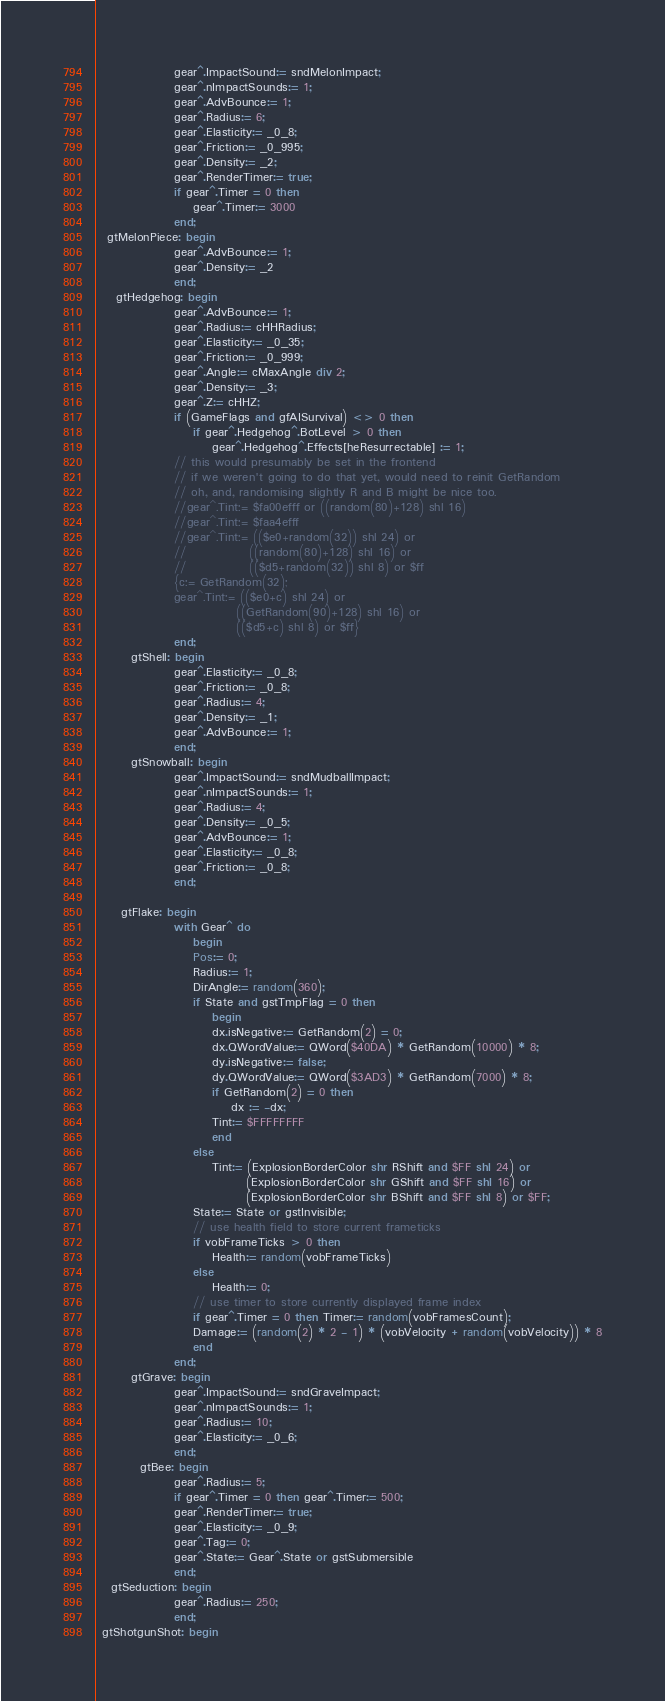Convert code to text. <code><loc_0><loc_0><loc_500><loc_500><_Pascal_>                gear^.ImpactSound:= sndMelonImpact;
                gear^.nImpactSounds:= 1;
                gear^.AdvBounce:= 1;
                gear^.Radius:= 6;
                gear^.Elasticity:= _0_8;
                gear^.Friction:= _0_995;
                gear^.Density:= _2;
                gear^.RenderTimer:= true;
                if gear^.Timer = 0 then
                    gear^.Timer:= 3000
                end;
  gtMelonPiece: begin
                gear^.AdvBounce:= 1;
                gear^.Density:= _2
                end;
    gtHedgehog: begin
                gear^.AdvBounce:= 1;
                gear^.Radius:= cHHRadius;
                gear^.Elasticity:= _0_35;
                gear^.Friction:= _0_999;
                gear^.Angle:= cMaxAngle div 2;
                gear^.Density:= _3;
                gear^.Z:= cHHZ;
                if (GameFlags and gfAISurvival) <> 0 then
                    if gear^.Hedgehog^.BotLevel > 0 then
                        gear^.Hedgehog^.Effects[heResurrectable] := 1;
                // this would presumably be set in the frontend
                // if we weren't going to do that yet, would need to reinit GetRandom
                // oh, and, randomising slightly R and B might be nice too.
                //gear^.Tint:= $fa00efff or ((random(80)+128) shl 16)
                //gear^.Tint:= $faa4efff
                //gear^.Tint:= (($e0+random(32)) shl 24) or
                //             ((random(80)+128) shl 16) or
                //             (($d5+random(32)) shl 8) or $ff
                {c:= GetRandom(32);
                gear^.Tint:= (($e0+c) shl 24) or
                             ((GetRandom(90)+128) shl 16) or
                             (($d5+c) shl 8) or $ff}
                end;
       gtShell: begin
                gear^.Elasticity:= _0_8;
                gear^.Friction:= _0_8;
                gear^.Radius:= 4;
                gear^.Density:= _1;
                gear^.AdvBounce:= 1;
                end;
       gtSnowball: begin
                gear^.ImpactSound:= sndMudballImpact;
                gear^.nImpactSounds:= 1;
                gear^.Radius:= 4;
                gear^.Density:= _0_5;
                gear^.AdvBounce:= 1;
                gear^.Elasticity:= _0_8;
                gear^.Friction:= _0_8;
                end;

     gtFlake: begin
                with Gear^ do
                    begin
                    Pos:= 0;
                    Radius:= 1;
                    DirAngle:= random(360);
                    if State and gstTmpFlag = 0 then
                        begin
                        dx.isNegative:= GetRandom(2) = 0;
                        dx.QWordValue:= QWord($40DA) * GetRandom(10000) * 8;
                        dy.isNegative:= false;
                        dy.QWordValue:= QWord($3AD3) * GetRandom(7000) * 8;
                        if GetRandom(2) = 0 then
                            dx := -dx;
                        Tint:= $FFFFFFFF
                        end
                    else
                        Tint:= (ExplosionBorderColor shr RShift and $FF shl 24) or
                               (ExplosionBorderColor shr GShift and $FF shl 16) or
                               (ExplosionBorderColor shr BShift and $FF shl 8) or $FF;
                    State:= State or gstInvisible;
                    // use health field to store current frameticks
                    if vobFrameTicks > 0 then
                        Health:= random(vobFrameTicks)
                    else
                        Health:= 0;
                    // use timer to store currently displayed frame index
                    if gear^.Timer = 0 then Timer:= random(vobFramesCount);
                    Damage:= (random(2) * 2 - 1) * (vobVelocity + random(vobVelocity)) * 8
                    end
                end;
       gtGrave: begin
                gear^.ImpactSound:= sndGraveImpact;
                gear^.nImpactSounds:= 1;
                gear^.Radius:= 10;
                gear^.Elasticity:= _0_6;
                end;
         gtBee: begin
                gear^.Radius:= 5;
                if gear^.Timer = 0 then gear^.Timer:= 500;
                gear^.RenderTimer:= true;
                gear^.Elasticity:= _0_9;
                gear^.Tag:= 0;
                gear^.State:= Gear^.State or gstSubmersible
                end;
   gtSeduction: begin
                gear^.Radius:= 250;
                end;
 gtShotgunShot: begin</code> 